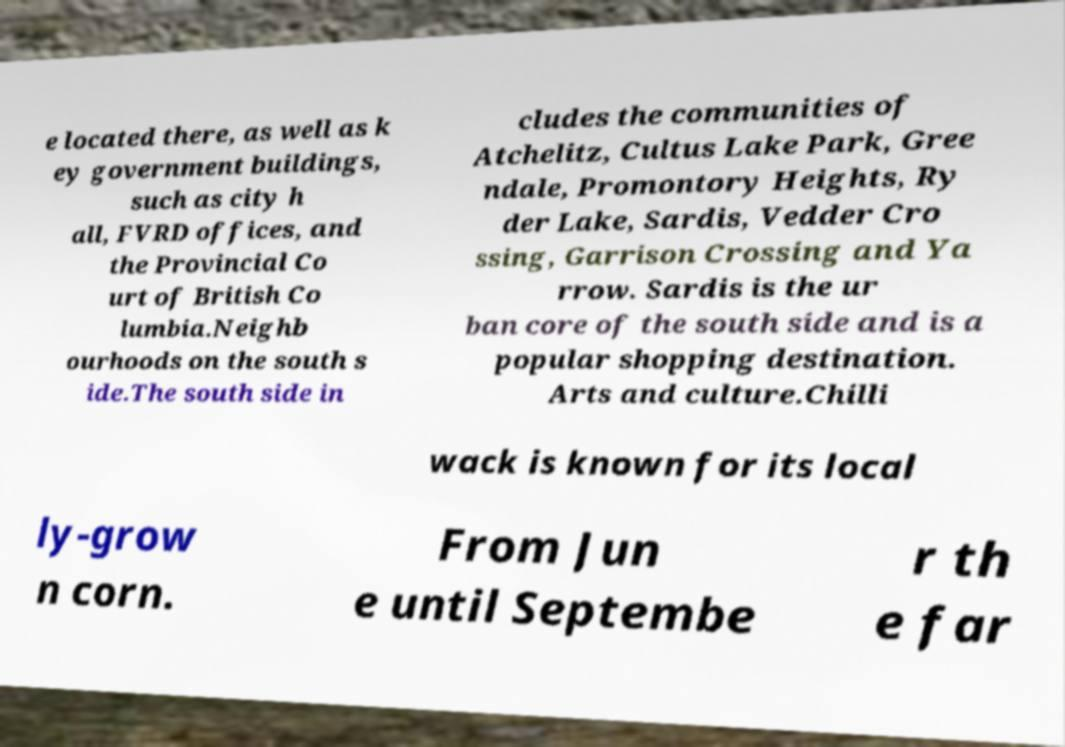Could you assist in decoding the text presented in this image and type it out clearly? e located there, as well as k ey government buildings, such as city h all, FVRD offices, and the Provincial Co urt of British Co lumbia.Neighb ourhoods on the south s ide.The south side in cludes the communities of Atchelitz, Cultus Lake Park, Gree ndale, Promontory Heights, Ry der Lake, Sardis, Vedder Cro ssing, Garrison Crossing and Ya rrow. Sardis is the ur ban core of the south side and is a popular shopping destination. Arts and culture.Chilli wack is known for its local ly-grow n corn. From Jun e until Septembe r th e far 